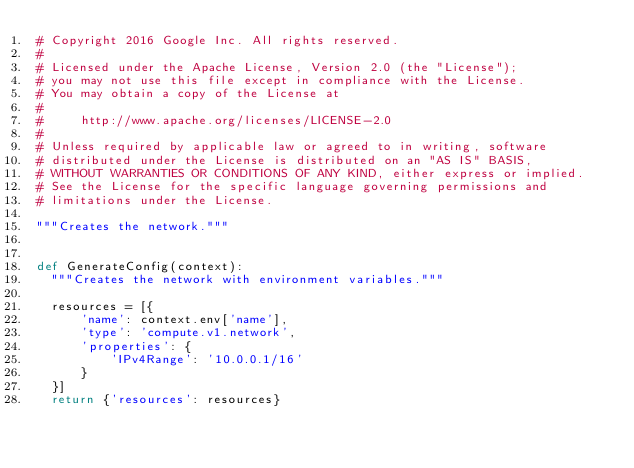Convert code to text. <code><loc_0><loc_0><loc_500><loc_500><_Python_># Copyright 2016 Google Inc. All rights reserved.
#
# Licensed under the Apache License, Version 2.0 (the "License");
# you may not use this file except in compliance with the License.
# You may obtain a copy of the License at
#
#     http://www.apache.org/licenses/LICENSE-2.0
#
# Unless required by applicable law or agreed to in writing, software
# distributed under the License is distributed on an "AS IS" BASIS,
# WITHOUT WARRANTIES OR CONDITIONS OF ANY KIND, either express or implied.
# See the License for the specific language governing permissions and
# limitations under the License.

"""Creates the network."""


def GenerateConfig(context):
  """Creates the network with environment variables."""

  resources = [{
      'name': context.env['name'],
      'type': 'compute.v1.network',
      'properties': {
          'IPv4Range': '10.0.0.1/16'
      }
  }]
  return {'resources': resources}
</code> 